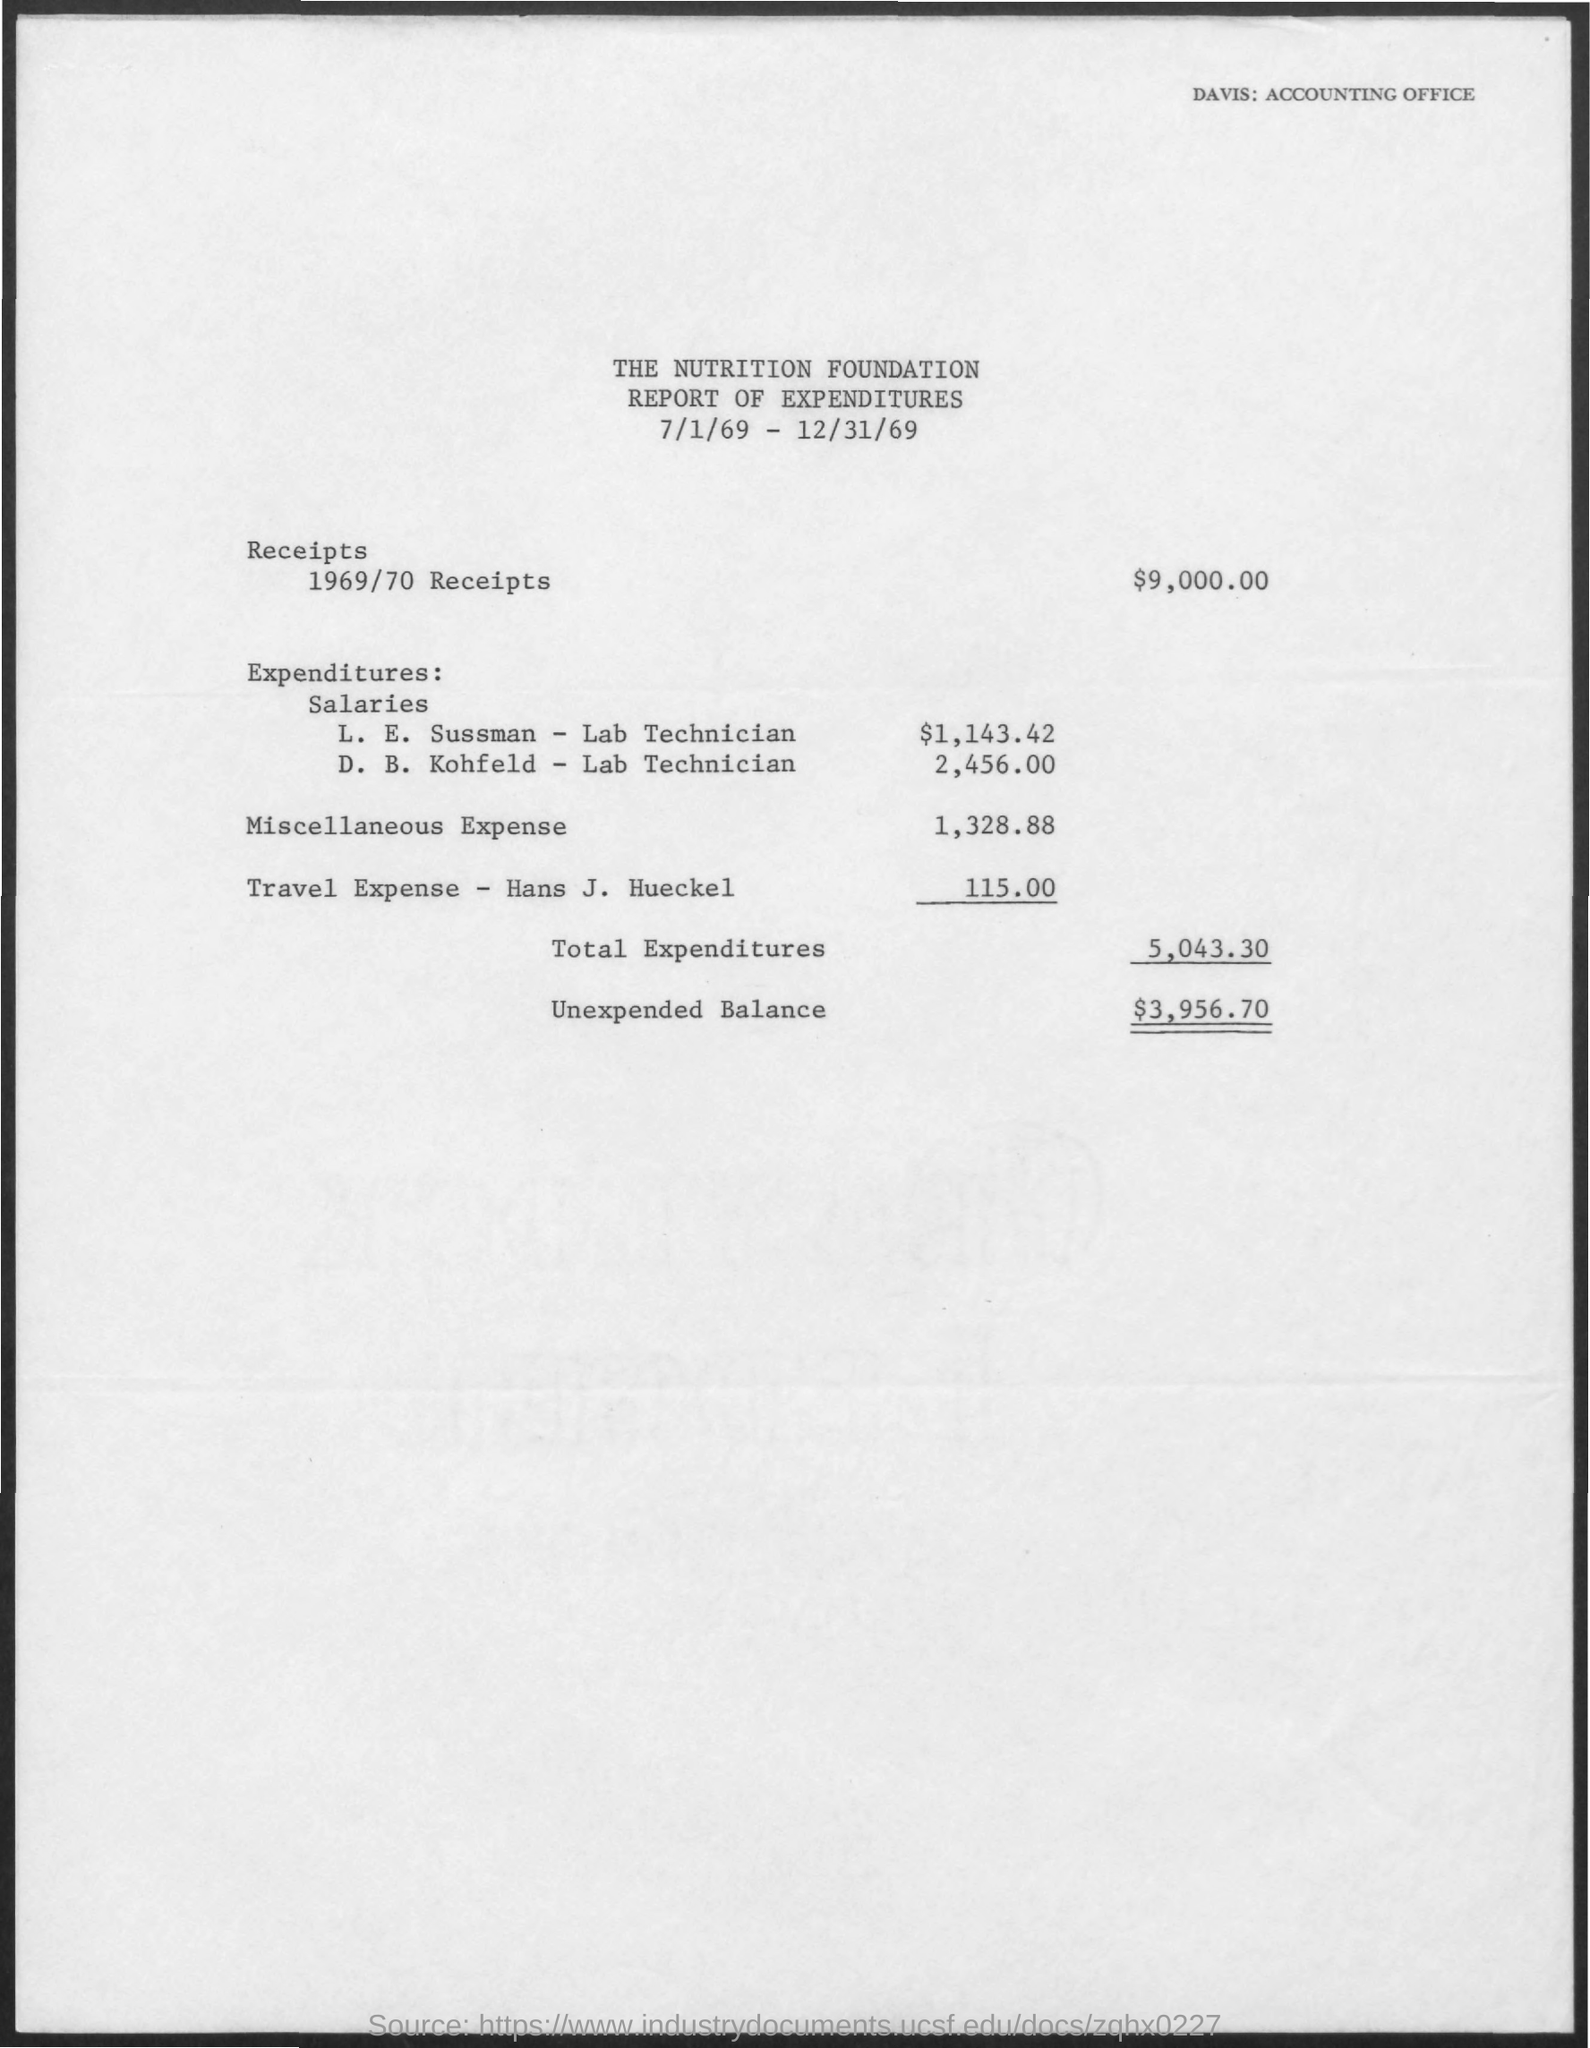What is the salary given to l.e. sussman -lab technician?
Keep it short and to the point. $ 1,143.42. What is the salary given to d.b.kohfeld - lab technician ?
Give a very brief answer. 2,456.00. What is the amount of miscellaneous expense mentioned in the given report ?
Keep it short and to the point. 1,328.88. What is the amount of the receipts for the year 1969/70 ?
Provide a short and direct response. $9,000.00. What is the amount of travel expenses for hans j. hueckel ?
Provide a succinct answer. 115.00. What is the amount of total expenditures mentioned in the given report ?
Your answer should be compact. 5,043.30. What is the amount of  unexpected balance mentioned in the given report ?
Give a very brief answer. $ 3,956.70. 